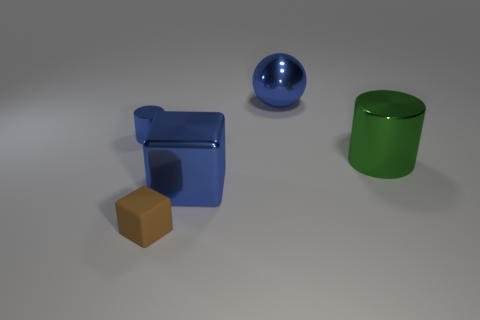Add 2 brown blocks. How many objects exist? 7 Subtract all blocks. How many objects are left? 3 Subtract all large red things. Subtract all small metallic objects. How many objects are left? 4 Add 2 brown things. How many brown things are left? 3 Add 1 small blue metallic objects. How many small blue metallic objects exist? 2 Subtract 0 purple cubes. How many objects are left? 5 